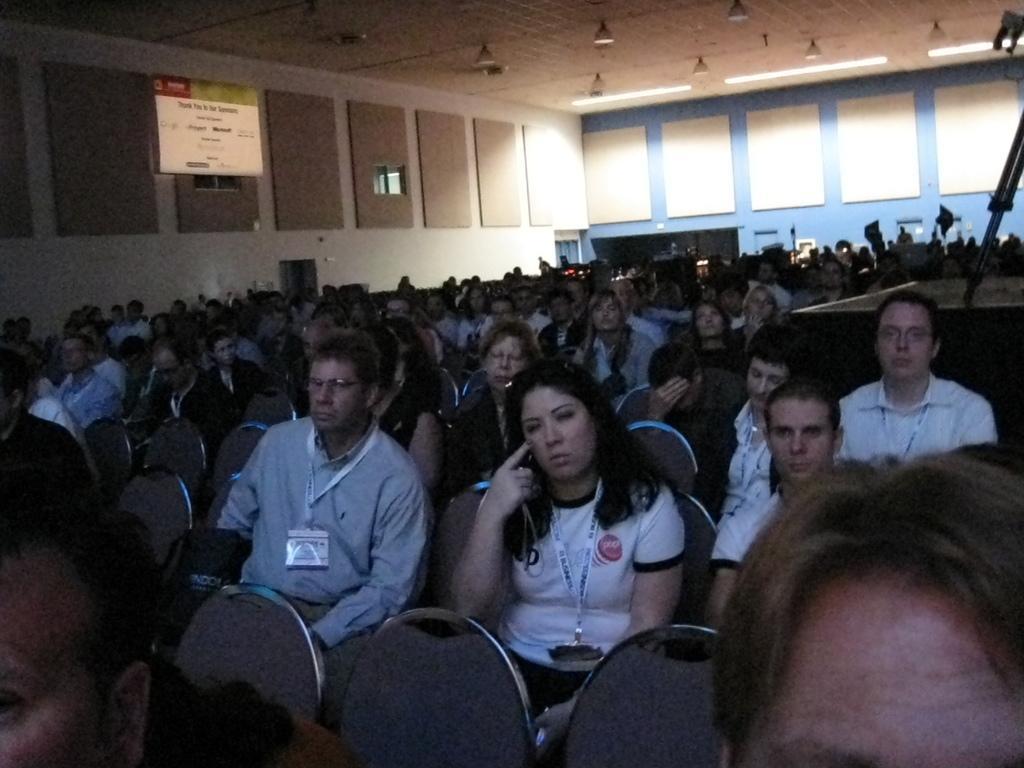Please provide a concise description of this image. In this picture we can see a group of people sitting on chairs, banner and in the background we can see walls. 